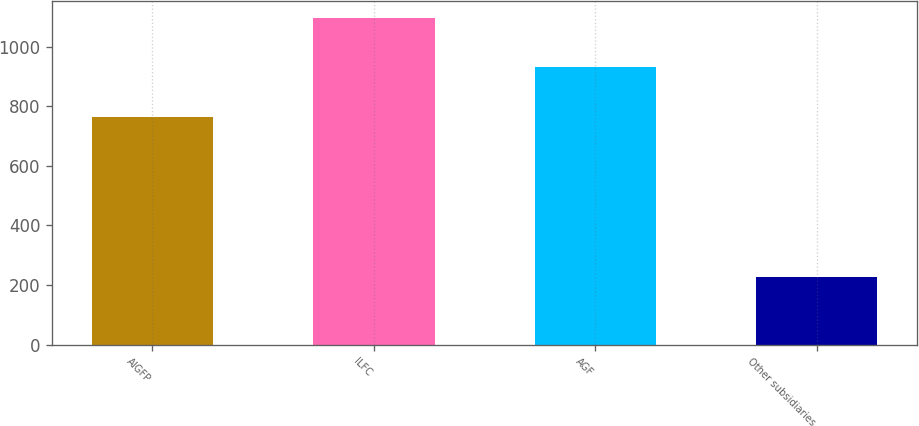Convert chart to OTSL. <chart><loc_0><loc_0><loc_500><loc_500><bar_chart><fcel>AIGFP<fcel>ILFC<fcel>AGF<fcel>Other subsidiaries<nl><fcel>765<fcel>1097<fcel>931<fcel>227<nl></chart> 